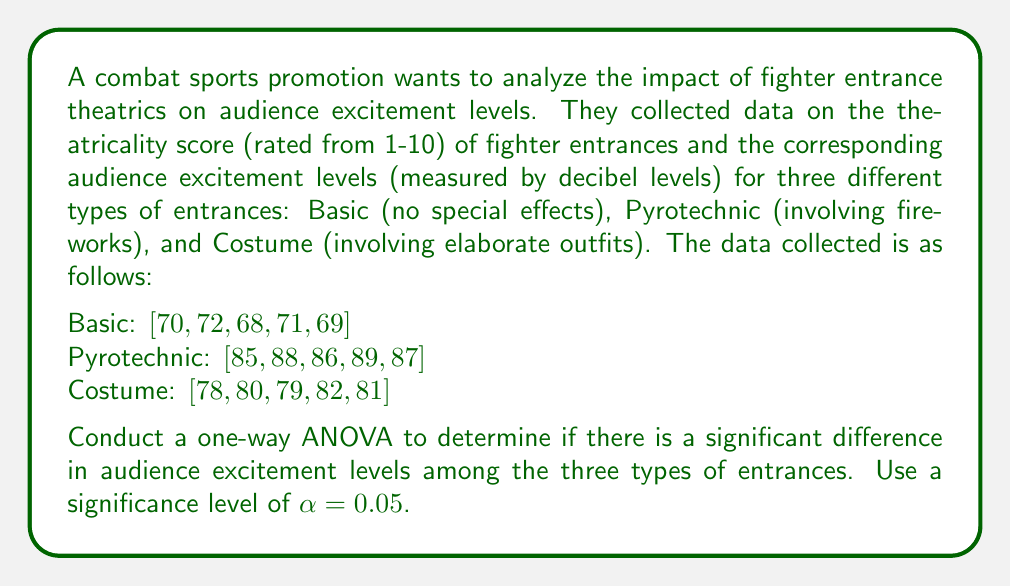Can you solve this math problem? To conduct a one-way ANOVA, we'll follow these steps:

1. Calculate the sum of squares between groups (SSB), sum of squares within groups (SSW), and total sum of squares (SST).
2. Calculate the degrees of freedom for between groups (dfB) and within groups (dfW).
3. Calculate the mean square between groups (MSB) and mean square within groups (MSW).
4. Calculate the F-statistic.
5. Compare the F-statistic to the critical F-value.

Step 1: Calculate sums of squares

First, we need to calculate the grand mean:
$$ \bar{X} = \frac{70 + 72 + 68 + 71 + 69 + 85 + 88 + 86 + 89 + 87 + 78 + 80 + 79 + 82 + 81}{15} = 79 $$

Now, let's calculate the group means:
$$ \bar{X}_{\text{Basic}} = 70, \quad \bar{X}_{\text{Pyrotechnic}} = 87, \quad \bar{X}_{\text{Costume}} = 80 $$

SSB:
$$ SSB = 5(70 - 79)^2 + 5(87 - 79)^2 + 5(80 - 79)^2 = 910 $$

SSW:
$$ SSW = [(70-70)^2 + (72-70)^2 + (68-70)^2 + (71-70)^2 + (69-70)^2] + $$
$$ [(85-87)^2 + (88-87)^2 + (86-87)^2 + (89-87)^2 + (87-87)^2] + $$
$$ [(78-80)^2 + (80-80)^2 + (79-80)^2 + (82-80)^2 + (81-80)^2] = 44 $$

SST:
$$ SST = SSB + SSW = 910 + 44 = 954 $$

Step 2: Calculate degrees of freedom

$$ df_B = k - 1 = 3 - 1 = 2 $$
$$ df_W = N - k = 15 - 3 = 12 $$

Where k is the number of groups and N is the total number of observations.

Step 3: Calculate mean squares

$$ MSB = \frac{SSB}{df_B} = \frac{910}{2} = 455 $$
$$ MSW = \frac{SSW}{df_W} = \frac{44}{12} = 3.67 $$

Step 4: Calculate F-statistic

$$ F = \frac{MSB}{MSW} = \frac{455}{3.67} = 124.09 $$

Step 5: Compare F-statistic to critical F-value

The critical F-value for α = 0.05, df_B = 2, and df_W = 12 is approximately 3.89.

Since our calculated F-statistic (124.09) is greater than the critical F-value (3.89), we reject the null hypothesis.
Answer: The one-way ANOVA results show a significant difference in audience excitement levels among the three types of entrances (F(2,12) = 124.09, p < 0.05). We reject the null hypothesis and conclude that the type of entrance theatrics significantly affects audience excitement levels. 